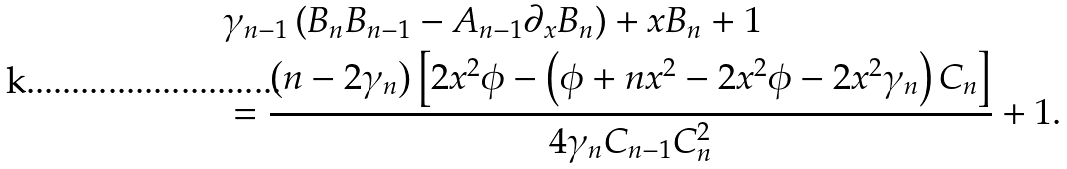<formula> <loc_0><loc_0><loc_500><loc_500>& \gamma _ { n - 1 } \left ( B _ { n } B _ { n - 1 } - A _ { n - 1 } \partial _ { x } B _ { n } \right ) + x B _ { n } + 1 \\ & = \frac { \left ( n - 2 \gamma _ { n } \right ) \left [ 2 x ^ { 2 } \phi - \left ( \phi + n x ^ { 2 } - 2 x ^ { 2 } \phi - 2 x ^ { 2 } \gamma _ { n } \right ) C _ { n } \right ] } { 4 \gamma _ { n } C _ { n - 1 } C _ { n } ^ { 2 } } + 1 .</formula> 